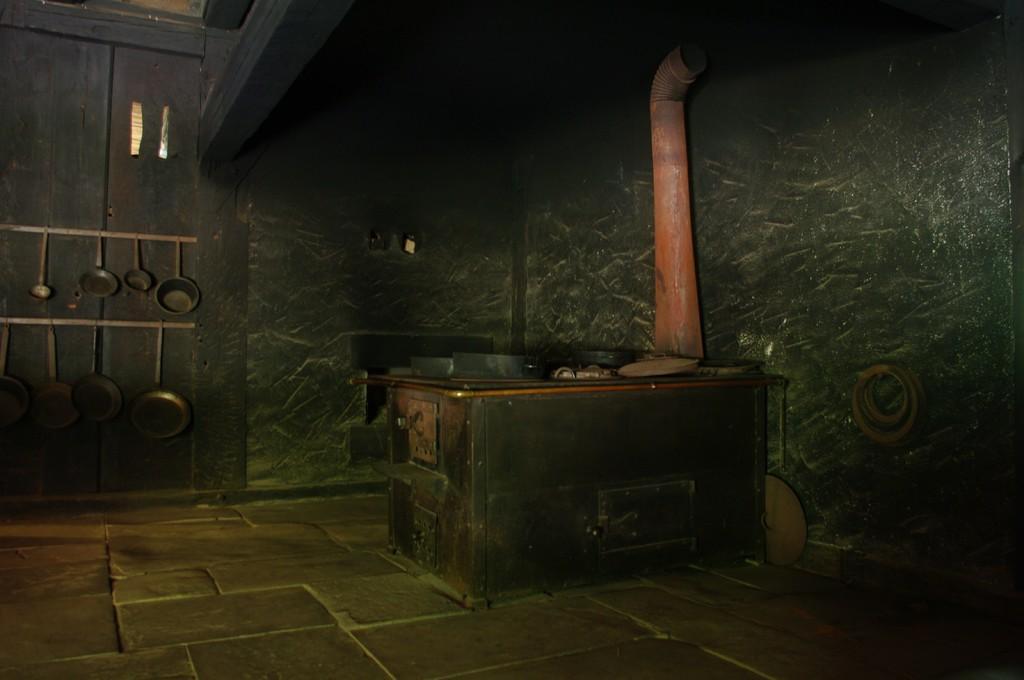Please provide a concise description of this image. In this image we can see inside view of a room. On the left side of the image we can see vessels. In the center of the image we can see a table with a pipe on it. 